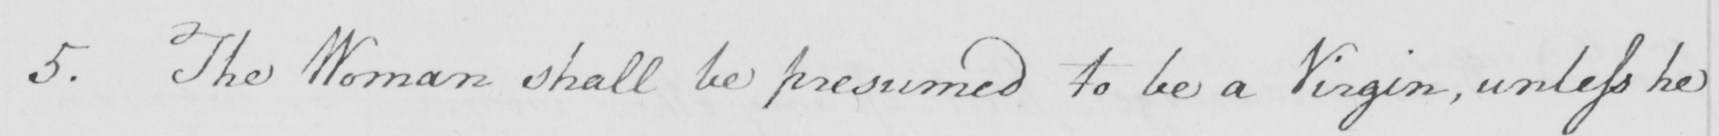Can you tell me what this handwritten text says? 5 . The Woman shall be presumed to be a Virgin , unless he 